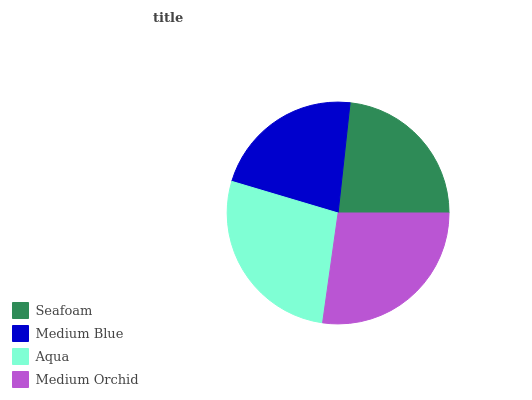Is Medium Blue the minimum?
Answer yes or no. Yes. Is Aqua the maximum?
Answer yes or no. Yes. Is Aqua the minimum?
Answer yes or no. No. Is Medium Blue the maximum?
Answer yes or no. No. Is Aqua greater than Medium Blue?
Answer yes or no. Yes. Is Medium Blue less than Aqua?
Answer yes or no. Yes. Is Medium Blue greater than Aqua?
Answer yes or no. No. Is Aqua less than Medium Blue?
Answer yes or no. No. Is Medium Orchid the high median?
Answer yes or no. Yes. Is Seafoam the low median?
Answer yes or no. Yes. Is Medium Blue the high median?
Answer yes or no. No. Is Medium Orchid the low median?
Answer yes or no. No. 